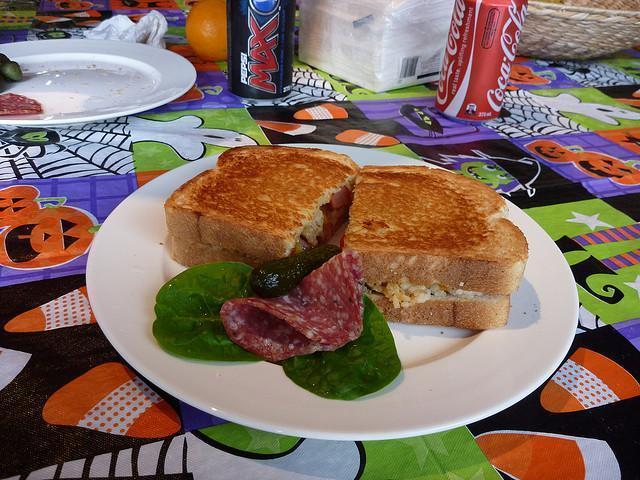What is the side dish?
Choose the right answer from the provided options to respond to the question.
Options: Pickle, fries, stuffing, carrots. Pickle. 